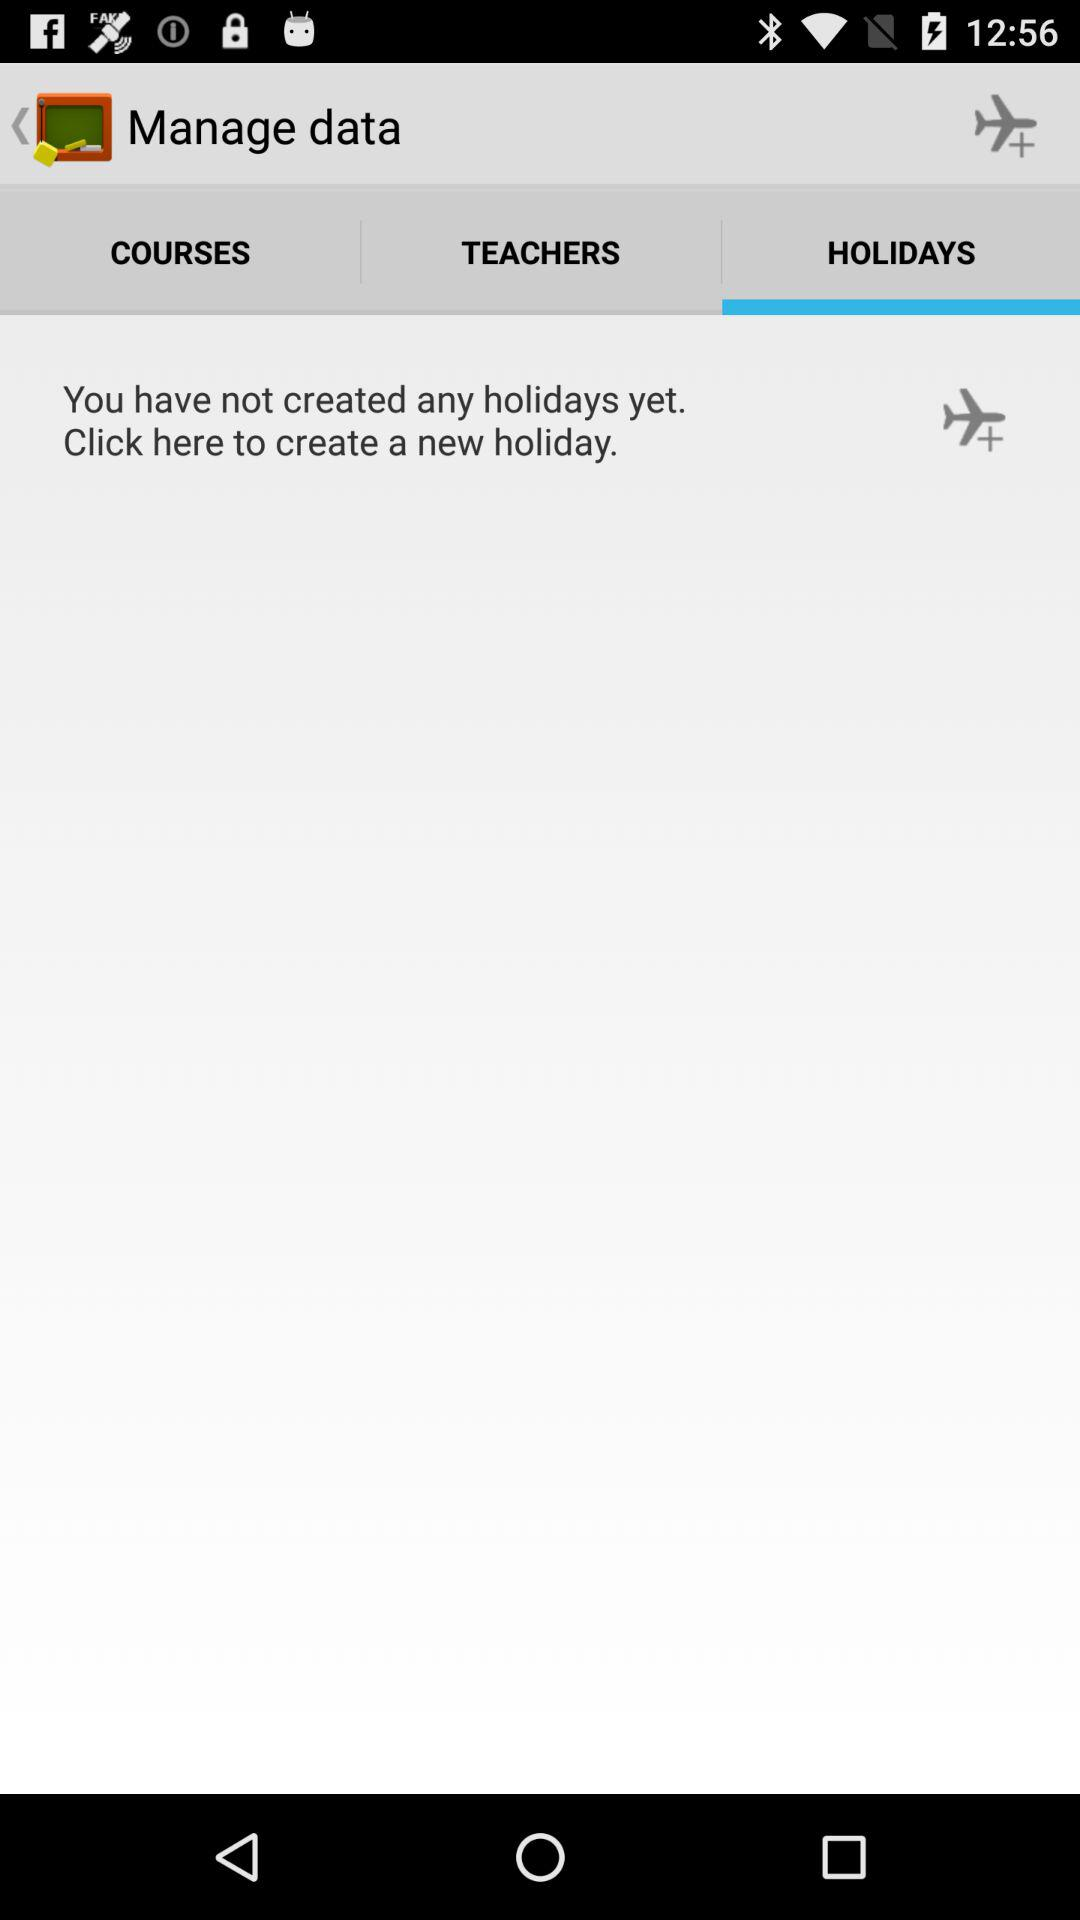Are there any created holidays? There are no created holidays. 